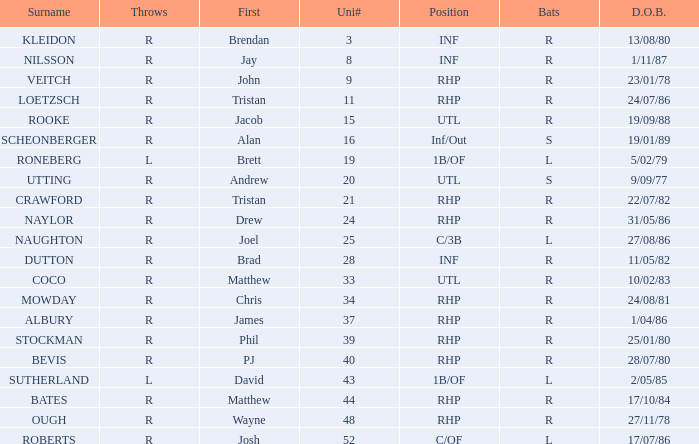Which Position has a Surname of naylor? RHP. 